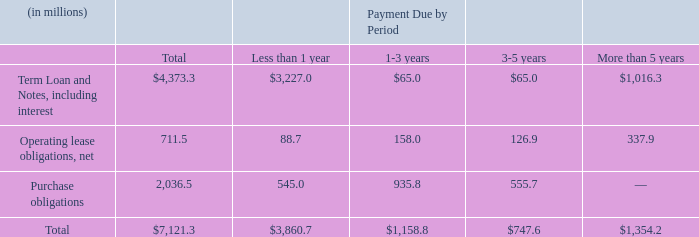Contractual Obligations
The following table summarizes our contractual obligations as of November 29, 2019:
As of November 29, 2019, our Term Loan’s carrying value was $2.25 billion. At our election, the Term Loan will bear interest at either (i) the London Interbank Offered Rate (“LIBOR”) plus a margin, based on our debt ratings, ranging from 0.500% to 1.000% or (ii) a base rate plus a margin, based on our debt ratings, ranging from 0.040% to 0.110%. Interest is payable periodically, in arrears, at the end of each interest period we elect. Based on the LIBOR rate at November 29, 2019, our estimated maximum commitment for interest payments was $23.2 million for the remaining duration of the Term Loan.
As of November 29, 2019, the carrying value of our Notes payable was $1.89 billion. Interest on our Notes is payable semi-annually, in arrears on February 1 and August 1. At November 29, 2019, our maximum commitment for interest payments was $200.1 million for the remaining duration of our Notes.
Our Term Loan and Revolving Credit Agreement contain similar financial covenants requiring us not to exceed a maximum leverage ratio. As of November 29, 2019, we were in compliance with this covenant. We believe this covenant will not impact our credit or cash in the coming fiscal year or restrict our ability to execute our business plan. Our senior notes do not contain any financial covenants.
Under the terms of our Term Loan and Revolving Credit Agreement, we are not prohibited from paying cash dividends unless payment would trigger an event of default or if one currently exists. We do not anticipate paying any cash dividends in the foreseeable future.
What is the estimated maximum commitment for interest payments for the remaining duration of the Term Loan based on the LIBOR rate? $23.2 million. What portion of term loan and notes, including interest have payment due more than 5 years?
Answer scale should be: percent. 1,016.3/4,373.3 
Answer: 23.24. What proportion of operating lease obligations (net) consists of payment obligations that due in less than a year? 88.7/711.5
Answer: 0.12. What is the carrying value of Notes payable as of November 29 2019?
Answer scale should be: billion. $1.89. How often is payment for interest on Notes made? Semi-annually. What is the value of contractual obligations for purchase obligations with payment due period of a maximum of 3 years?
Answer scale should be: million. 545+935.8
Answer: 1480.8. 